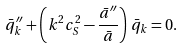Convert formula to latex. <formula><loc_0><loc_0><loc_500><loc_500>\bar { q } _ { k } ^ { \prime \prime } + \left ( k ^ { 2 } c _ { S } ^ { 2 } - \frac { \bar { a } ^ { \prime \prime } } { \bar { a } } \right ) \, \bar { q } _ { k } = 0 .</formula> 